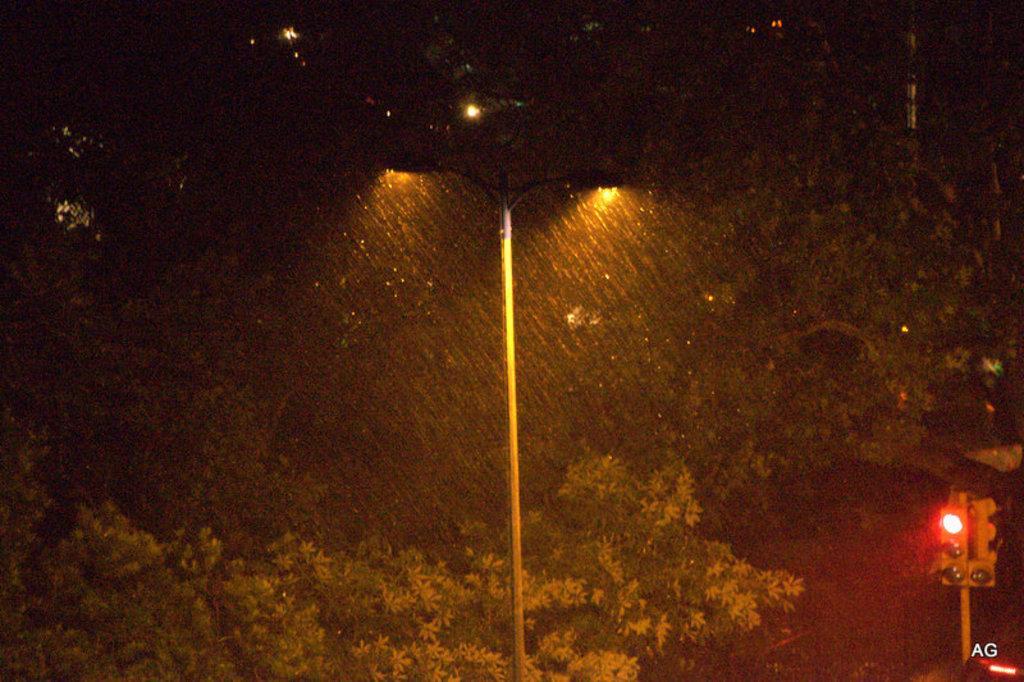Could you give a brief overview of what you see in this image? In this image we can see the night view and it is raining and there is a street light in the middle of the image and we can see the traffic lights on the right side of the image. There are some trees in the background. 